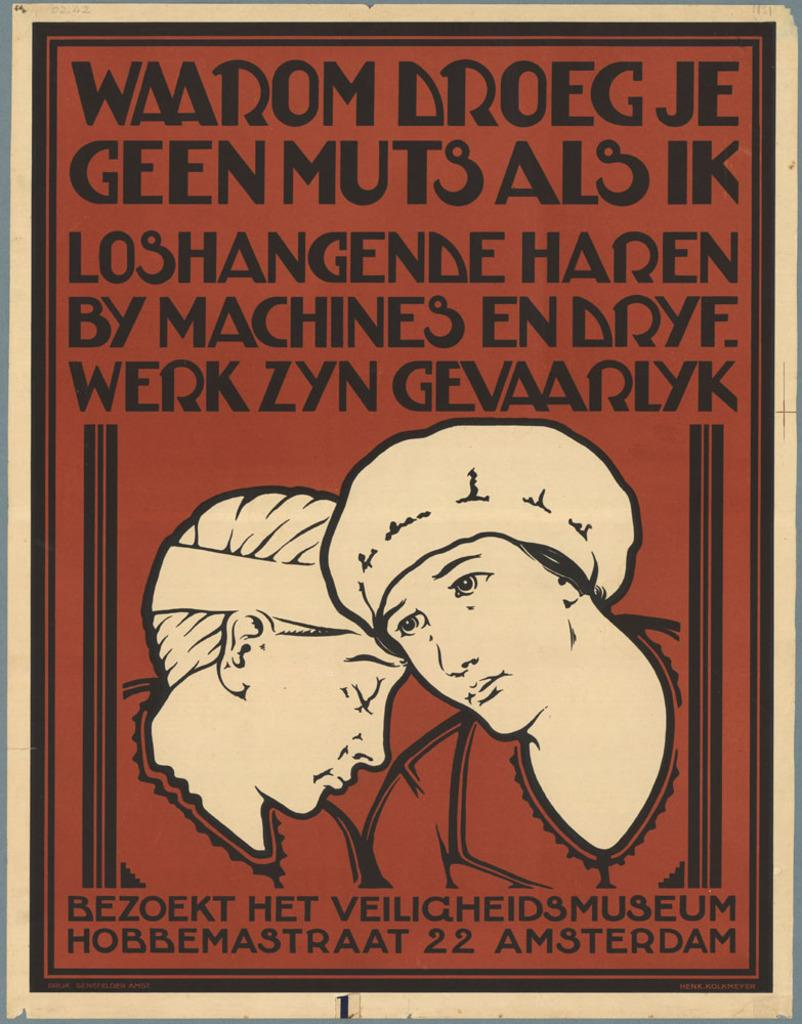How many people are in the image? There are two persons in the image. What else can be seen in the image besides the people? There is text or writing on the image. What color is the background of the image? The background of the image is brown. What type of brain can be seen in the image? There is no brain present in the image. How does the friction affect the interaction between the two persons in the image? The image does not depict any interaction between the two persons, and there is no information about friction. 